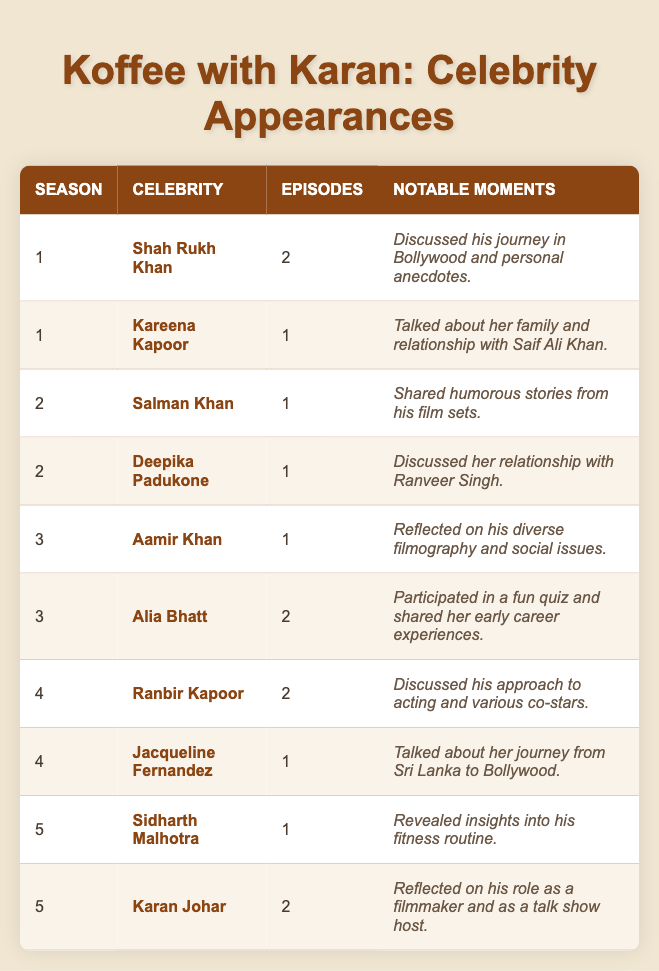What is the total number of episodes featuring Shah Rukh Khan? Shah Rukh Khan appears in Season 1 for a total of 2 episodes, so we only need to consider that entry in the table.
Answer: 2 Which celebrity appeared in the most episodes? Looking through the table, Alia Bhatt and Karan Johar each have 2 episodes; all others have fewer. Therefore, the answer involves identifying these celebrities with the maximum count.
Answer: Alia Bhatt and Karan Johar In which season did Jacqueline Fernandez appear? Jacqueline Fernandez appears in Season 4, as per her entry in the table.
Answer: Season 4 How many episodes did celebrities appear in across all seasons? To find the total, we must sum the number of episodes in each entry: 2 (Shah Rukh Khan) + 1 (Kareena Kapoor) + 1 (Salman Khan) + 1 (Deepika Padukone) + 1 (Aamir Khan) + 2 (Alia Bhatt) + 2 (Ranbir Kapoor) + 1 (Jacqueline Fernandez) + 1 (Sidharth Malhotra) + 2 (Karan Johar), which totals to 13.
Answer: 13 Did Deepika Padukone appear in more than one episode? Deepika Padukone appears in 1 episode according to her entry in the table, which means the answer to this question is negative.
Answer: No How many different celebrities appeared throughout all five seasons? By counting the number of unique celebrity names listed in the table, we find there are 10: Shah Rukh Khan, Kareena Kapoor, Salman Khan, Deepika Padukone, Aamir Khan, Alia Bhatt, Ranbir Kapoor, Jacqueline Fernandez, Sidharth Malhotra, and Karan Johar.
Answer: 10 Which season had the highest number of celebrity appearances, and how many were there? To determine this, we'll count the appearances per season: Season 1 has 2, Season 2 has 2, Season 3 has 2, Season 4 has 2, and Season 5 has 2; thus, no single season stands out. All seasons are tied with 2 entries.
Answer: All seasons have 2 appearances What notable moment did Alia Bhatt share during her appearances? According to the table, Alia Bhatt participated in a fun quiz and shared her early career experiences. This can be found directly in her entry under notable moments.
Answer: Participated in a fun quiz and shared her early career experiences How does the number of episodes featuring Karan Johar compare to those featuring Sidharth Malhotra? Karan Johar appears in 2 episodes, while Sidharth Malhotra appears in 1 episode. Therefore, the comparison shows Karan Johar has one more episode than Sidharth Malhotra.
Answer: Karan Johar has 1 more episode than Sidharth Malhotra Which celebrity appeared only once and what was a notable moment from their appearance? From the table, both Salman Khan and Jacqueline Fernandez appeared only once. Notable moments include Salman sharing humorous stories and Jacqueline talking about her journey from Sri Lanka to Bollywood.
Answer: Salman Khan and Jacqueline Fernandez; notable moments vary 